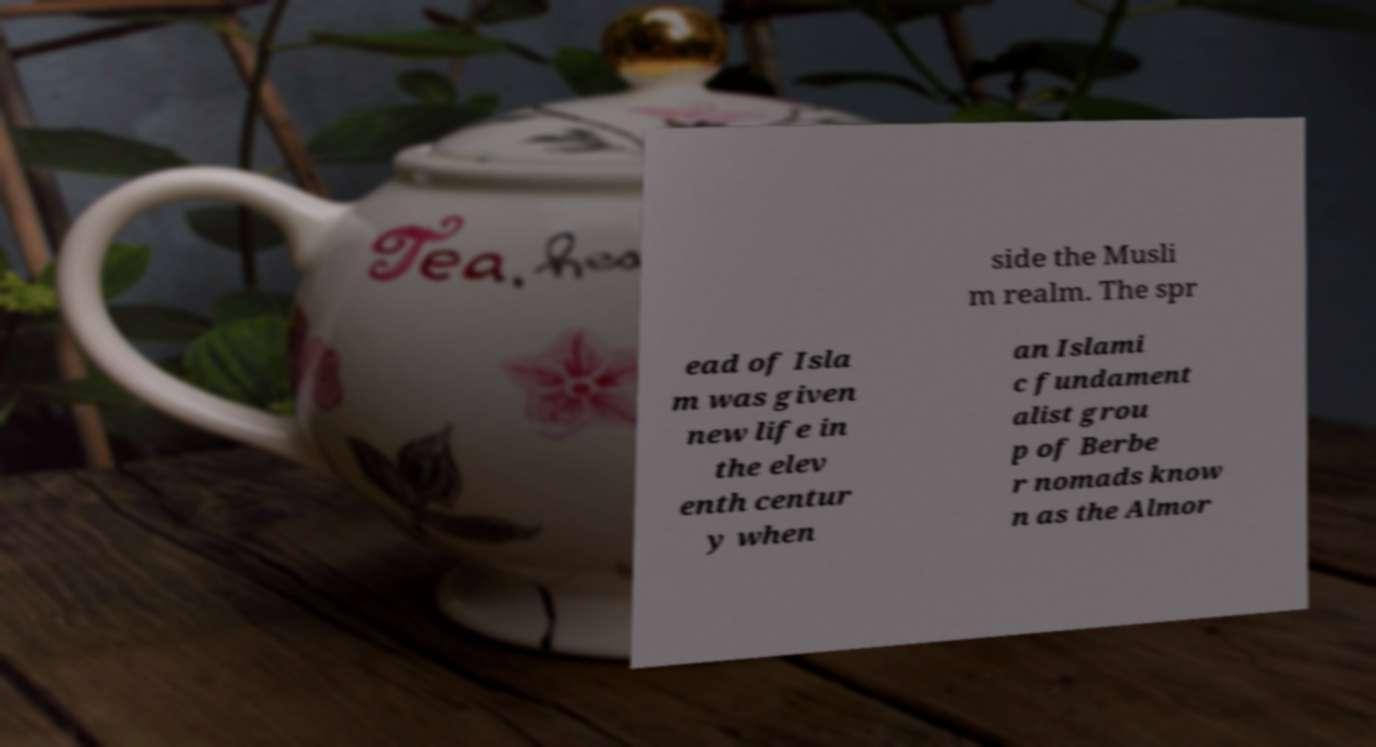Please read and relay the text visible in this image. What does it say? side the Musli m realm. The spr ead of Isla m was given new life in the elev enth centur y when an Islami c fundament alist grou p of Berbe r nomads know n as the Almor 